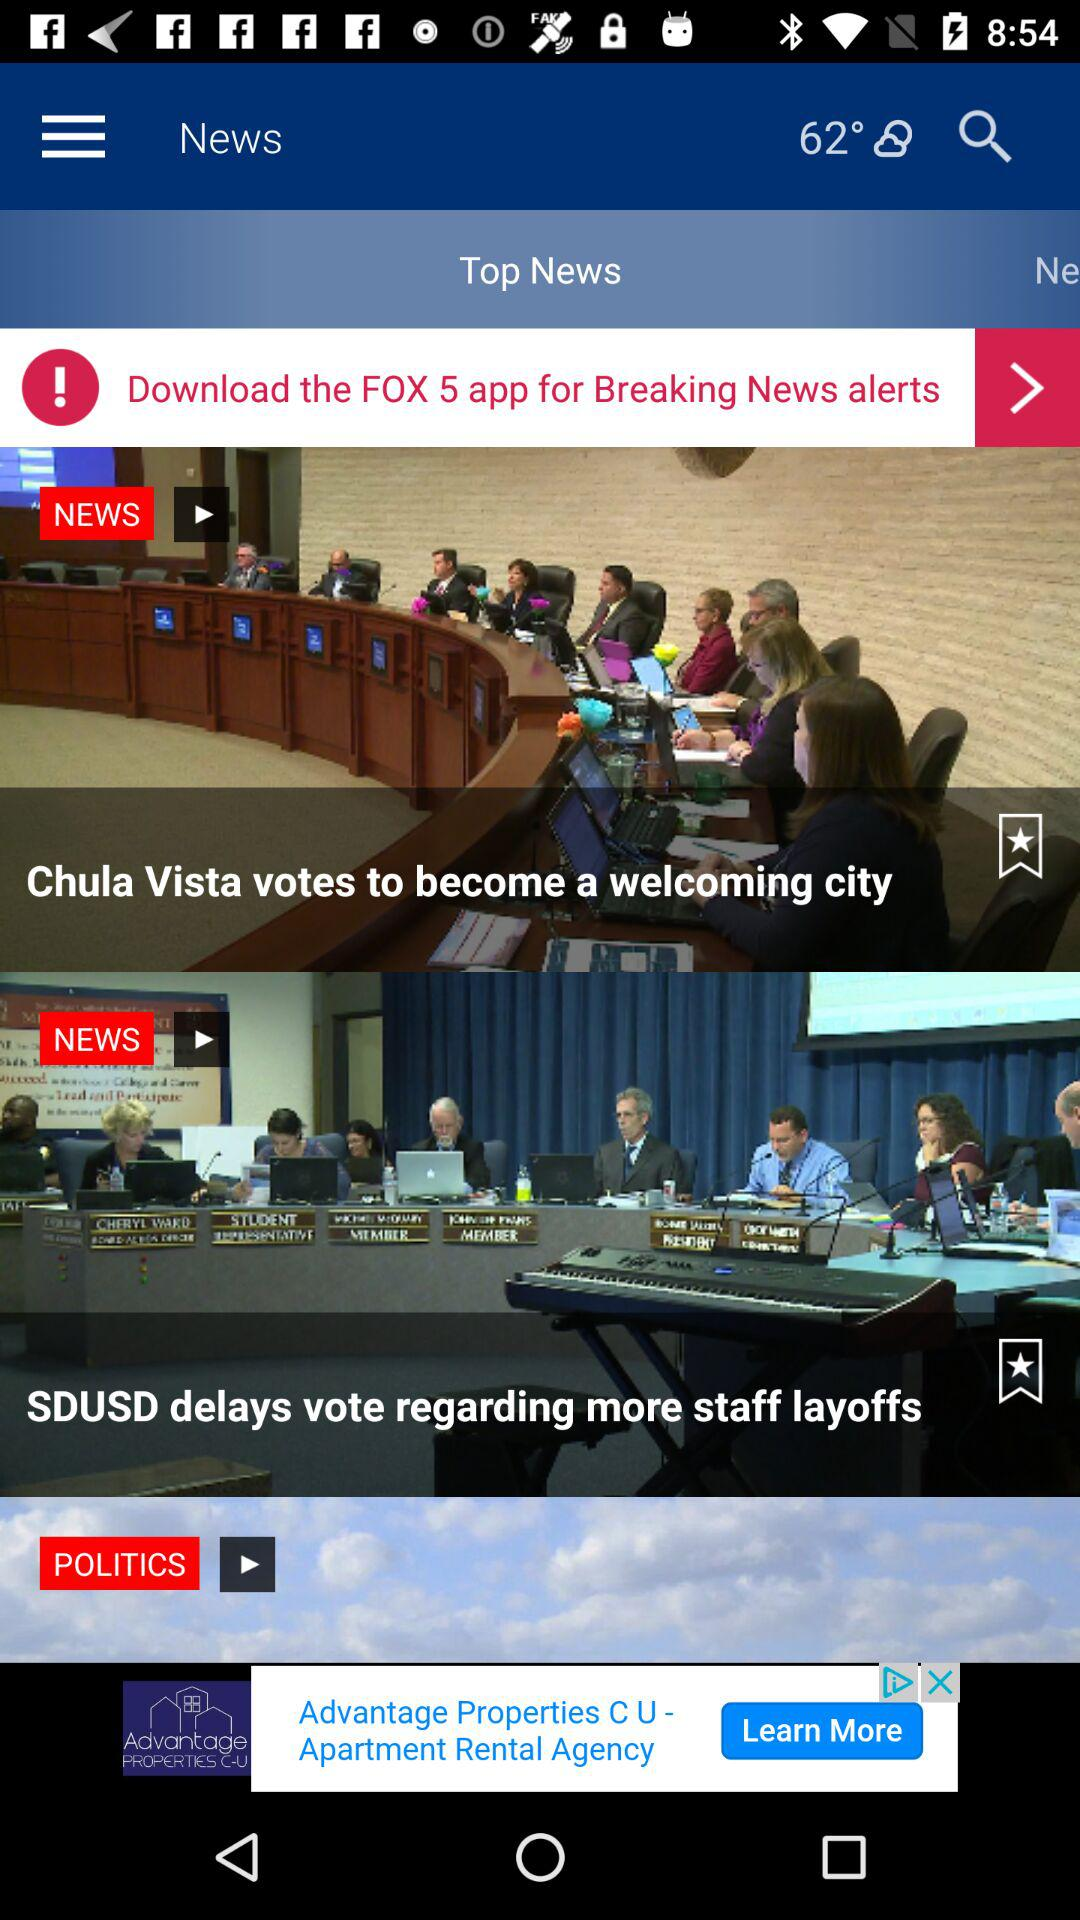Which is the currently selected tab? The currently selected tab is "Top News". 